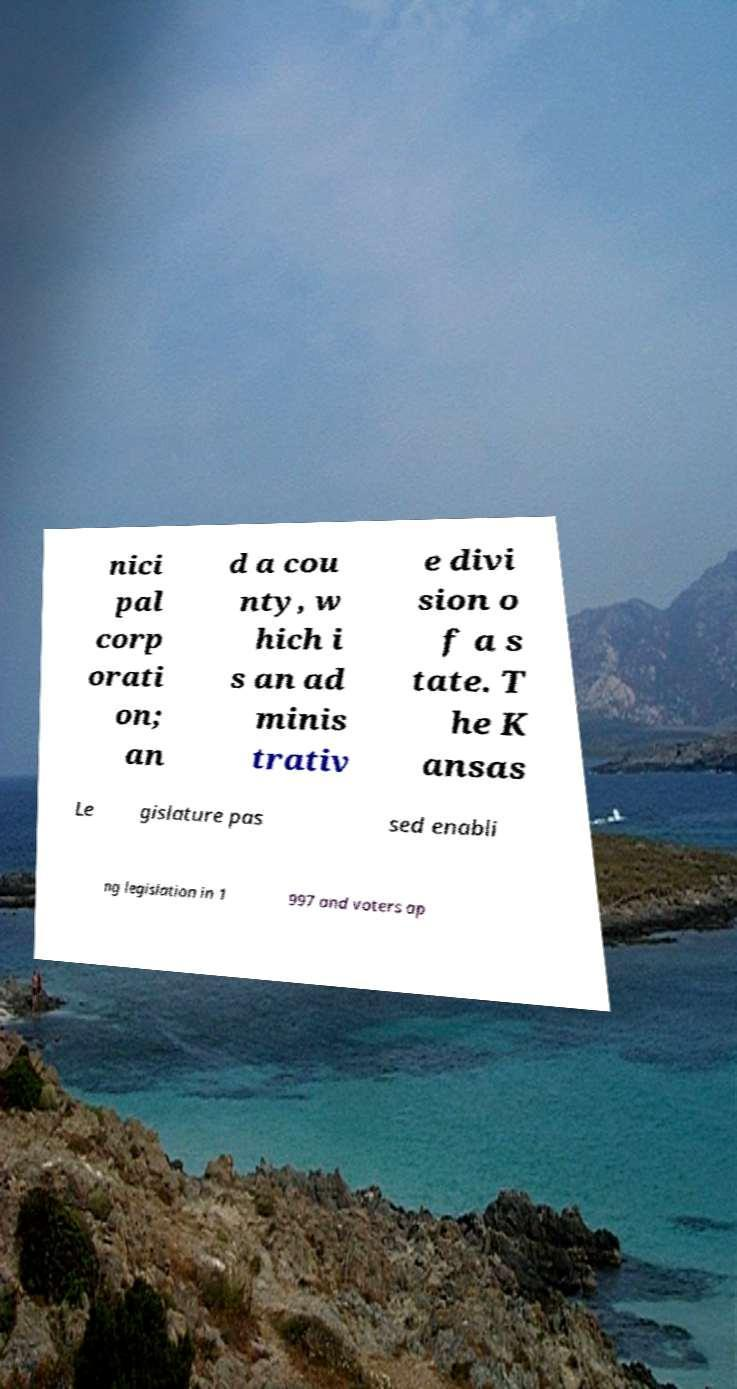For documentation purposes, I need the text within this image transcribed. Could you provide that? nici pal corp orati on; an d a cou nty, w hich i s an ad minis trativ e divi sion o f a s tate. T he K ansas Le gislature pas sed enabli ng legislation in 1 997 and voters ap 